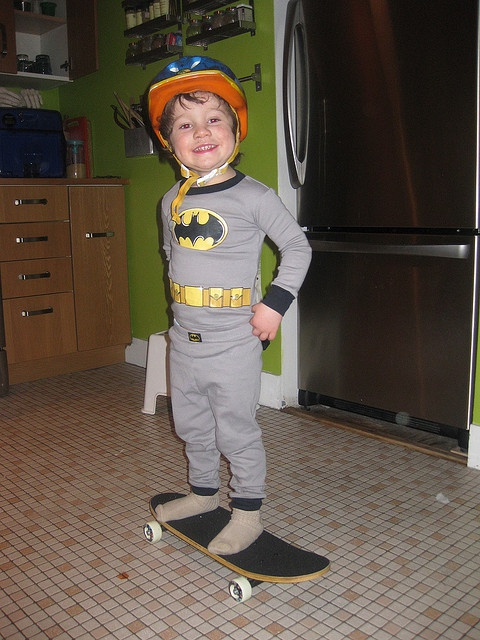Describe the objects in this image and their specific colors. I can see refrigerator in black, gray, and darkgray tones, people in black, darkgray, lightpink, and gray tones, skateboard in black, tan, and gray tones, cup in black and gray tones, and cup in black and gray tones in this image. 